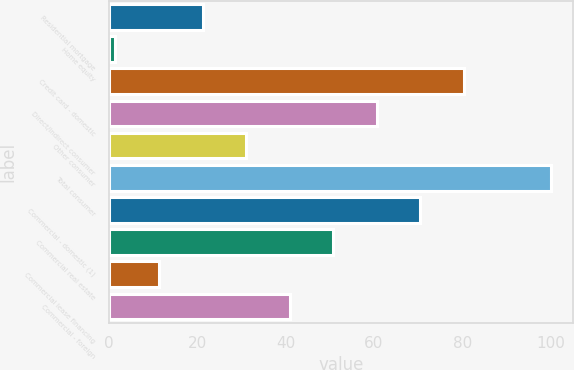<chart> <loc_0><loc_0><loc_500><loc_500><bar_chart><fcel>Residential mortgage<fcel>Home equity<fcel>Credit card - domestic<fcel>Direct/Indirect consumer<fcel>Other consumer<fcel>Total consumer<fcel>Commercial - domestic (1)<fcel>Commercial real estate<fcel>Commercial lease financing<fcel>Commercial - foreign<nl><fcel>21.18<fcel>1.48<fcel>80.28<fcel>60.58<fcel>31.03<fcel>99.98<fcel>70.43<fcel>50.73<fcel>11.33<fcel>40.88<nl></chart> 